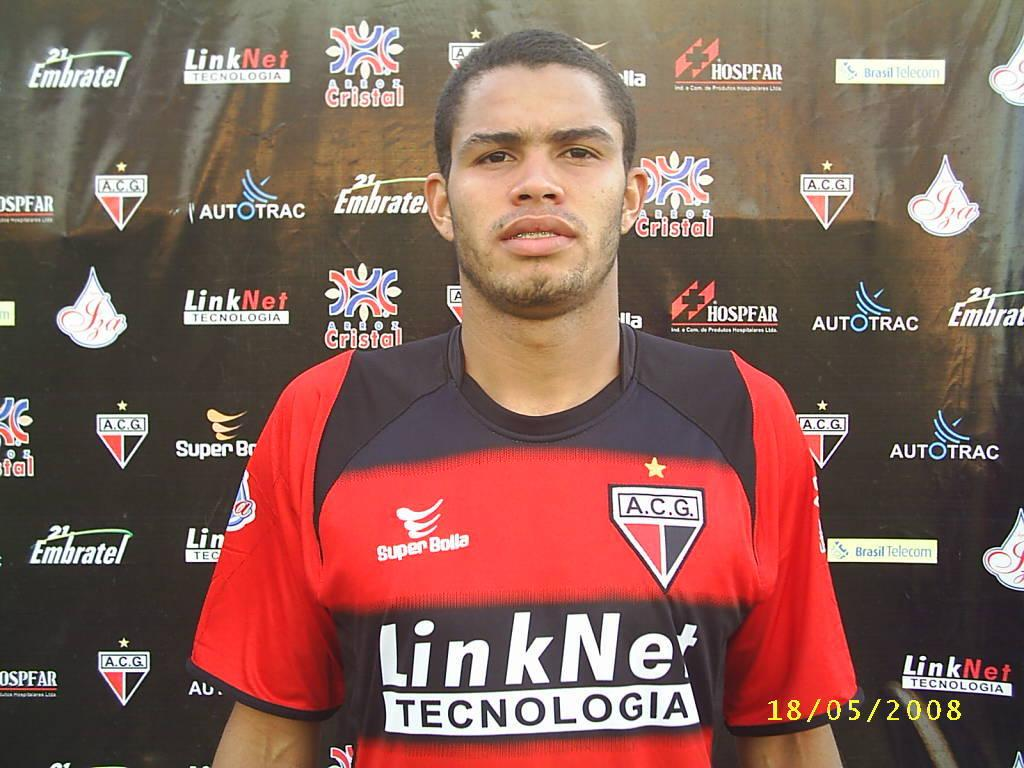<image>
Give a short and clear explanation of the subsequent image. A man in a LinkNet Technologia soccer shirt stands to get his photo taken 